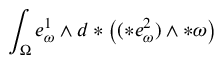<formula> <loc_0><loc_0><loc_500><loc_500>\int _ { \Omega } e _ { \omega } ^ { 1 } \wedge d \ast \left ( ( \ast e _ { \omega } ^ { 2 } ) \wedge \ast \omega \right )</formula> 